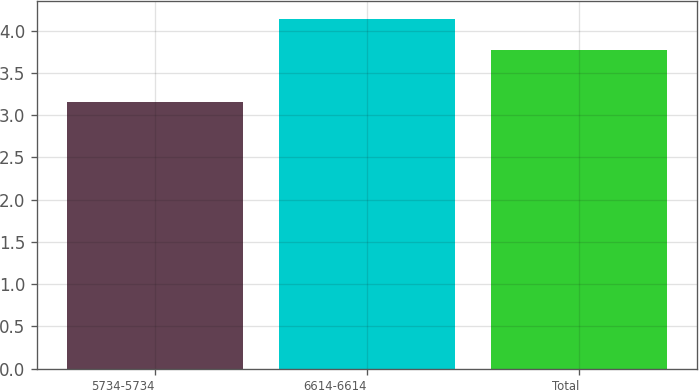<chart> <loc_0><loc_0><loc_500><loc_500><bar_chart><fcel>5734-5734<fcel>6614-6614<fcel>Total<nl><fcel>3.15<fcel>4.14<fcel>3.77<nl></chart> 